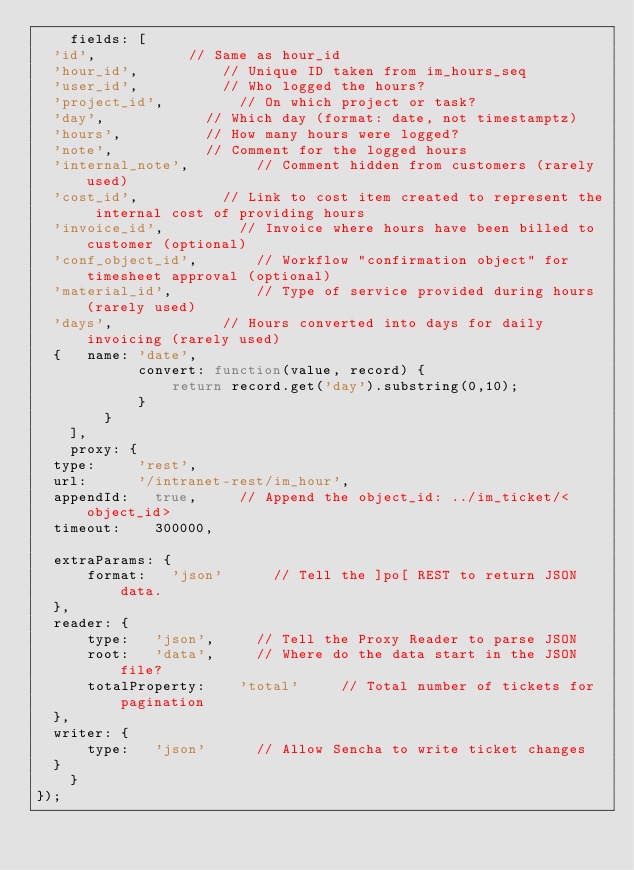<code> <loc_0><loc_0><loc_500><loc_500><_JavaScript_>    fields: [
	'id',						// Same as hour_id
	'hour_id',					// Unique ID taken from im_hours_seq
	'user_id',					// Who logged the hours?
	'project_id',					// On which project or task?
	'day',						// Which day (format: date, not timestamptz)
	'hours',					// How many hours were logged?
	'note',						// Comment for the logged hours
	'internal_note',				// Comment hidden from customers (rarely used)
	'cost_id',					// Link to cost item created to represent the internal cost of providing hours
	'invoice_id',					// Invoice where hours have been billed to customer (optional)
	'conf_object_id',				// Workflow "confirmation object" for timesheet approval (optional)
	'material_id',					// Type of service provided during hours (rarely used)
	'days',    					// Hours converted into days for daily invoicing (rarely used)
	{   name: 'date',
            convert: function(value, record) {
                return record.get('day').substring(0,10);
            }
        }
    ],
    proxy: {
	type:			'rest',
	url:			'/intranet-rest/im_hour',
	appendId:		true,			// Append the object_id: ../im_ticket/<object_id>
	timeout:		300000,
	
	extraParams: {
	    format:		'json'			// Tell the ]po[ REST to return JSON data.
	},
	reader: {
	    type:		'json',			// Tell the Proxy Reader to parse JSON
	    root:		'data',			// Where do the data start in the JSON file?
	    totalProperty:  	'total'			// Total number of tickets for pagination
	},
	writer: {
	    type:		'json'			// Allow Sencha to write ticket changes
	}
    }
});

</code> 